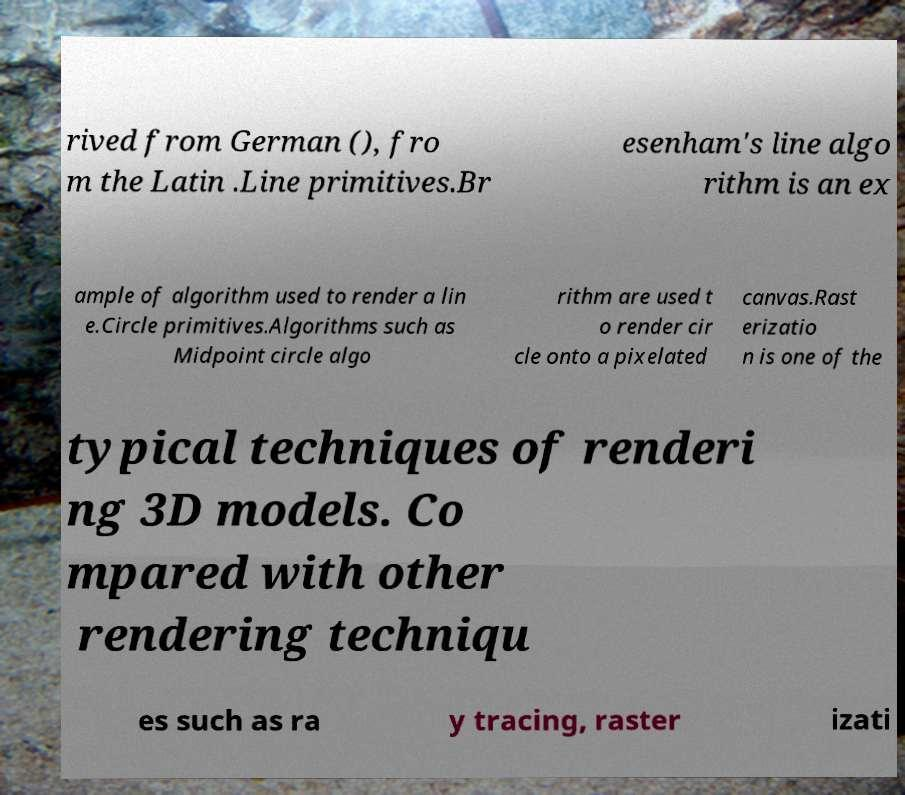Could you assist in decoding the text presented in this image and type it out clearly? rived from German (), fro m the Latin .Line primitives.Br esenham's line algo rithm is an ex ample of algorithm used to render a lin e.Circle primitives.Algorithms such as Midpoint circle algo rithm are used t o render cir cle onto a pixelated canvas.Rast erizatio n is one of the typical techniques of renderi ng 3D models. Co mpared with other rendering techniqu es such as ra y tracing, raster izati 